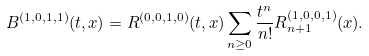<formula> <loc_0><loc_0><loc_500><loc_500>B ^ { ( 1 , 0 , 1 , 1 ) } ( t , x ) = R ^ { ( 0 , 0 , 1 , 0 ) } ( t , x ) \sum _ { n \geq 0 } \frac { t ^ { n } } { n ! } R _ { n + 1 } ^ { ( 1 , 0 , 0 , 1 ) } ( x ) .</formula> 